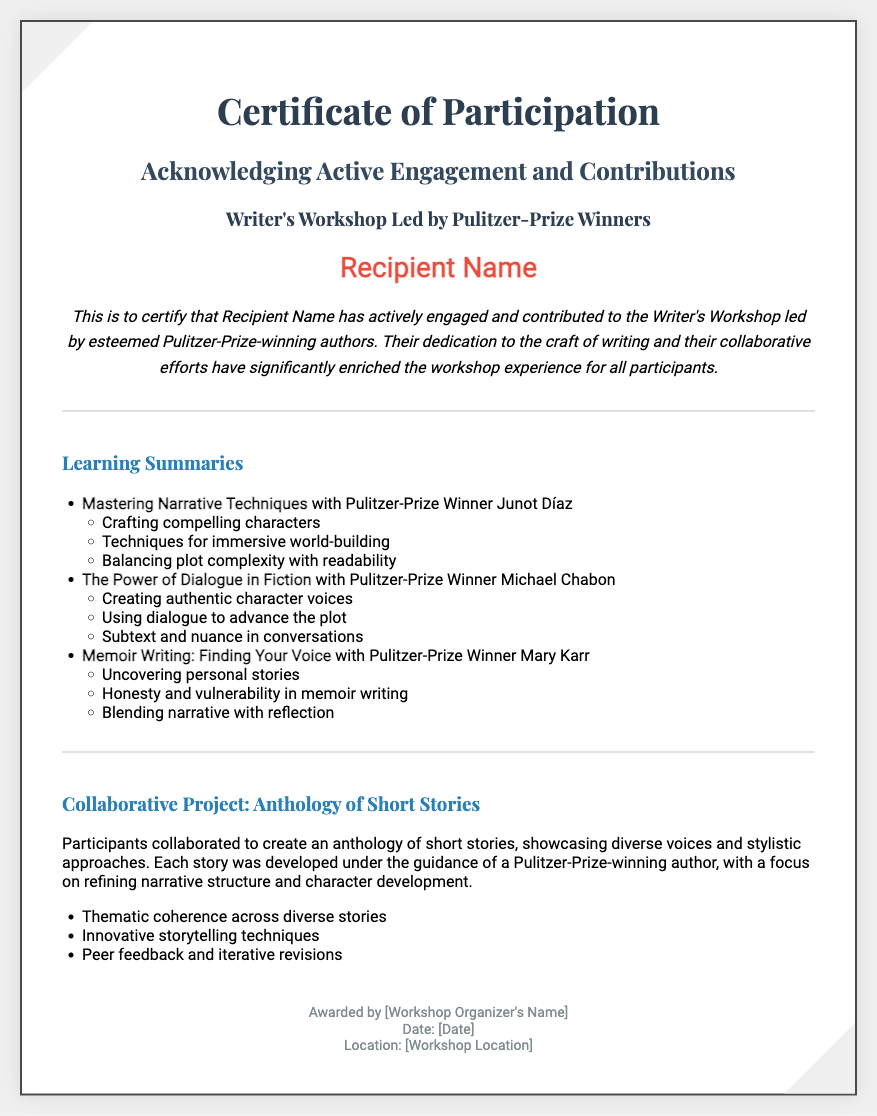What is the title of the certificate? The title of the certificate is displayed prominently at the top of the document.
Answer: Certificate of Participation Who led the Writer's Workshop? The workshop was led by esteemed Pulitzer-Prize-winning authors.
Answer: Pulitzer-Prize Winners What is the name of one Pulitzer-Prize winner mentioned? Specific Pulitzer-Prize winners are listed in the learning summaries section.
Answer: Junot Díaz What is one topic covered in the learning summaries? Topics are outlined in the learning summaries section, each associated with a Pulitzer-Prize winner.
Answer: Mastering Narrative Techniques What is the focus of the collaborative project? The collaborative project description highlights the participants' efforts in a specific area.
Answer: Anthology of Short Stories What type of project did the participants create? The project type is clearly identified in the document and is relevant to the collaborative aspect.
Answer: Anthology What is one element of the collaborative project mentioned? The collaborative project includes specific aspects that were important in its development.
Answer: Thematic coherence Who awarded the certificate? The name of the workshop organizer is mentioned in the footer of the document.
Answer: Workshop Organizer's Name What is the document's background color? The background color of the document is prominent and consistent throughout the design.
Answer: Light gray 